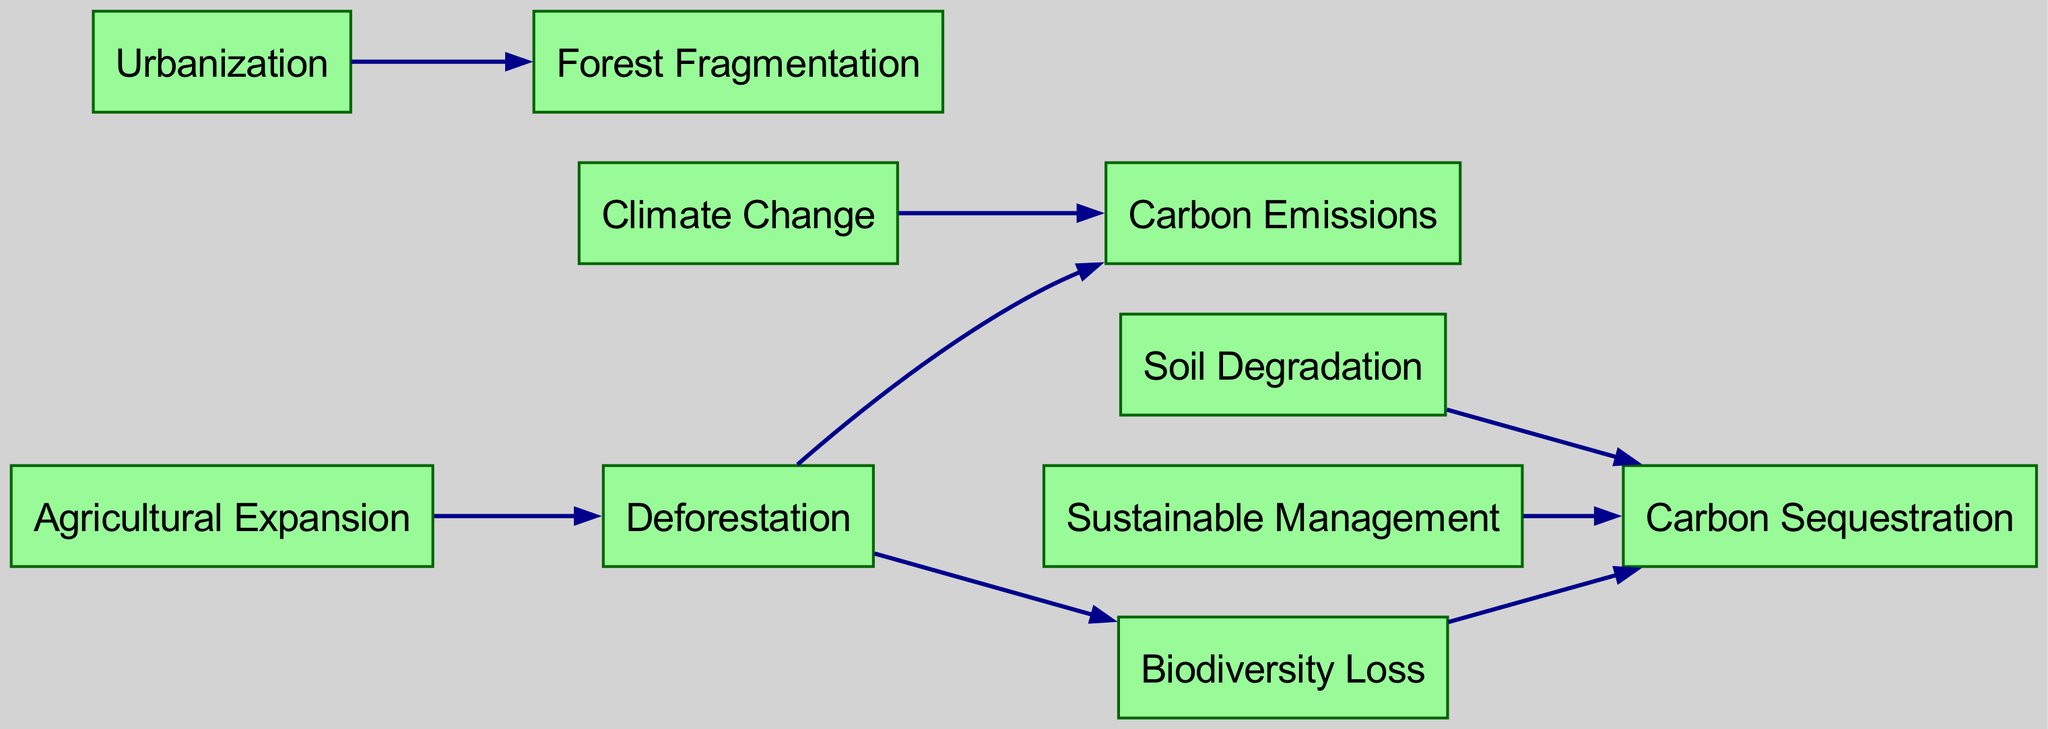What are the nodes present in the diagram? The diagram consists of the following nodes: Deforestation, Urbanization, Agricultural Expansion, Forest Fragmentation, Soil Degradation, Carbon Emissions, Biodiversity Loss, Sustainable Management, Climate Change, and Carbon Sequestration.
Answer: Deforestation, Urbanization, Agricultural Expansion, Forest Fragmentation, Soil Degradation, Carbon Emissions, Biodiversity Loss, Sustainable Management, Climate Change, Carbon Sequestration How many edges are in the diagram? By counting the connections listed in the edges section, the total number of edges is 8.
Answer: 8 Which node directly connects to Carbon Emissions? Upon reviewing the directed edges, it is clear that both Deforestation and Climate Change directly connect to Carbon Emissions.
Answer: Deforestation, Climate Change What is the effect of Deforestation on Biodiversity Loss? The directed edge from Deforestation to Biodiversity Loss indicates that Deforestation has a direct negative impact on Biodiversity Loss.
Answer: Deforestation How does Soil Degradation affect Carbon Sequestration? There is a direct edge from Soil Degradation to Carbon Sequestration, meaning that Soil Degradation negatively affects the Carbon Sequestration potential.
Answer: Reduces Which node promotes Carbon Sequestration? The diagram shows a directed edge from Sustainable Management to Carbon Sequestration, indicating that Sustainable Management promotes Carbon Sequestration.
Answer: Sustainable Management What is the relationship between Urbanization and Forest Fragmentation? Urbanization directly leads to Forest Fragmentation as shown by the directed edge connecting them.
Answer: Leads to How does Agricultural Expansion influence Deforestation? Agricultural Expansion has a direct edge to Deforestation, indicating that Agricultural Expansion contributes to or causes Deforestation.
Answer: Causes Which two factors directly affect Carbon Sequestration? The edges indicate that Biodiversity Loss and Soil Degradation directly affect Carbon Sequestration. Both are shown with directed edges leading towards it.
Answer: Biodiversity Loss, Soil Degradation 